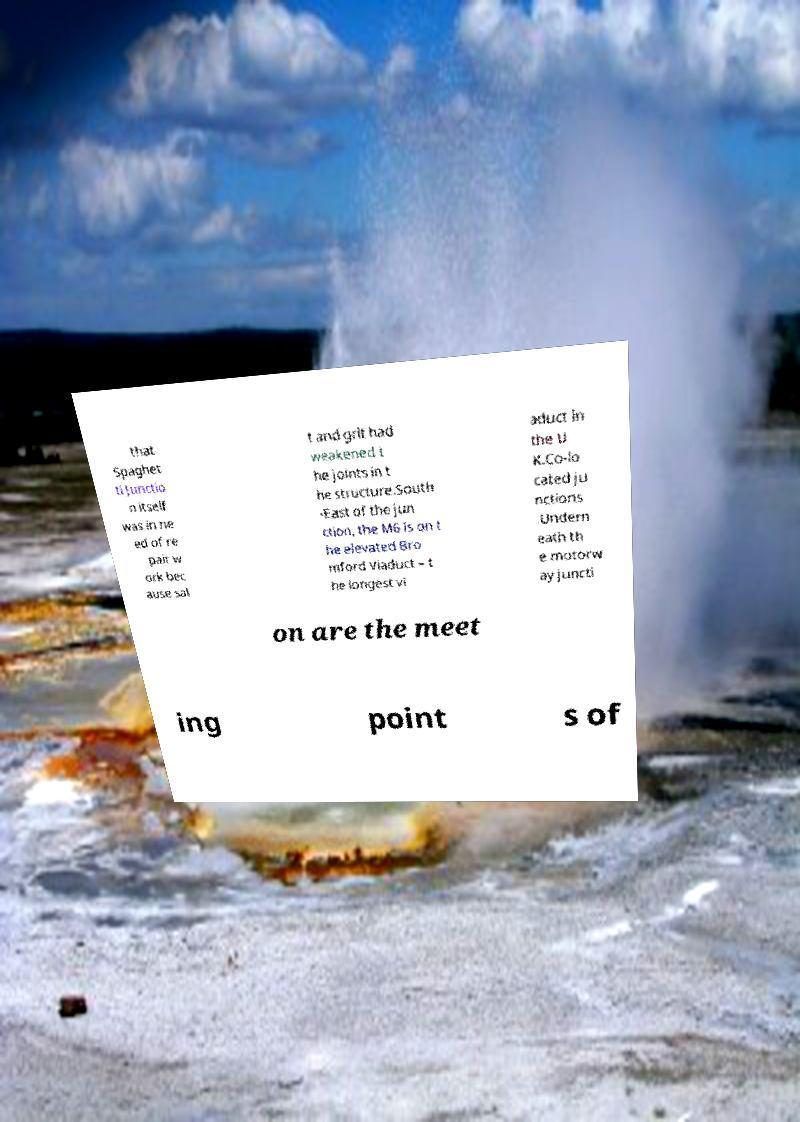What messages or text are displayed in this image? I need them in a readable, typed format. that Spaghet ti Junctio n itself was in ne ed of re pair w ork bec ause sal t and grit had weakened t he joints in t he structure.South -East of the jun ction, the M6 is on t he elevated Bro mford Viaduct – t he longest vi aduct in the U K.Co-lo cated ju nctions .Undern eath th e motorw ay juncti on are the meet ing point s of 